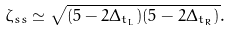Convert formula to latex. <formula><loc_0><loc_0><loc_500><loc_500>\zeta _ { s s } \simeq \sqrt { ( 5 - 2 \Delta _ { t _ { L } } ) ( 5 - 2 \Delta _ { t _ { R } } ) } .</formula> 